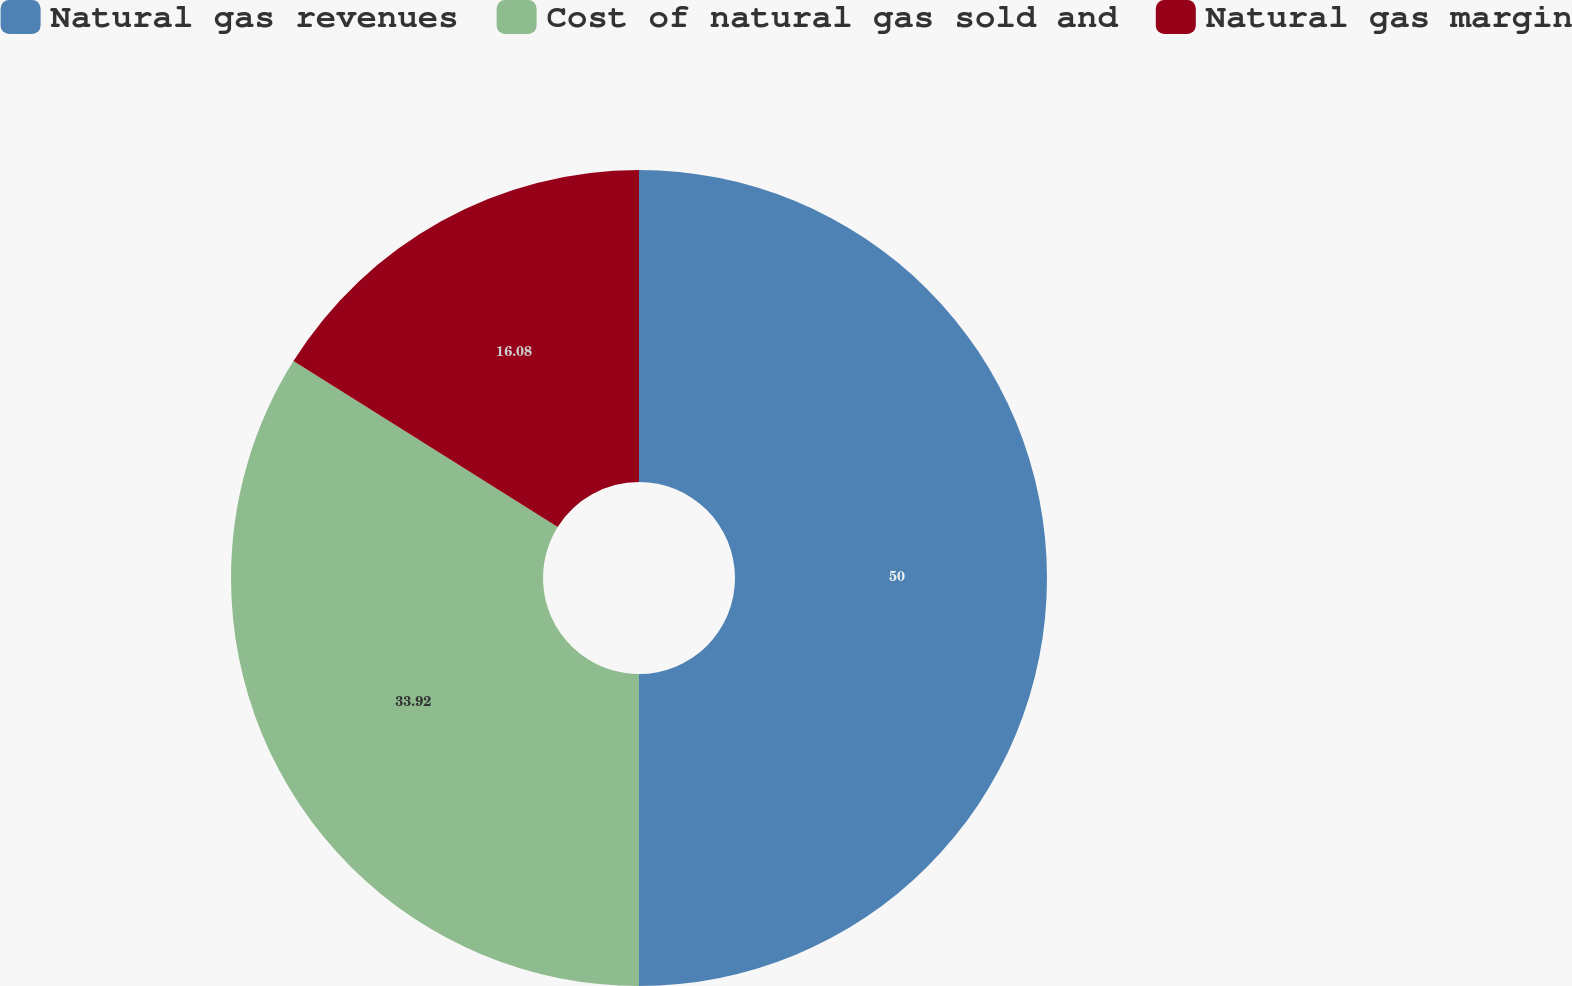Convert chart. <chart><loc_0><loc_0><loc_500><loc_500><pie_chart><fcel>Natural gas revenues<fcel>Cost of natural gas sold and<fcel>Natural gas margin<nl><fcel>50.0%<fcel>33.92%<fcel>16.08%<nl></chart> 